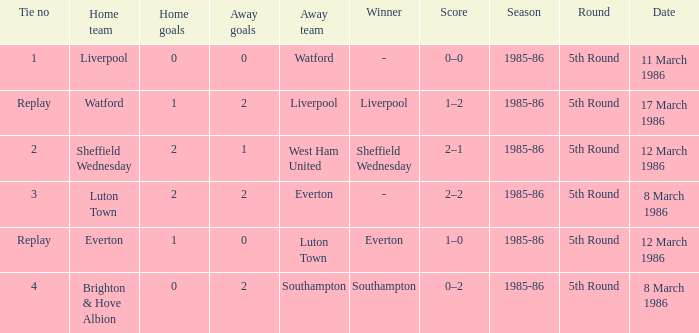What transpired with southampton's tie? 4.0. Can you give me this table as a dict? {'header': ['Tie no', 'Home team', 'Home goals', 'Away goals', 'Away team', 'Winner', 'Score', 'Season', 'Round', 'Date'], 'rows': [['1', 'Liverpool', '0', '0', 'Watford', '-', '0–0', '1985-86', '5th Round', '11 March 1986'], ['Replay', 'Watford', '1', '2', 'Liverpool', 'Liverpool', '1–2', '1985-86', '5th Round', '17 March 1986'], ['2', 'Sheffield Wednesday', '2', '1', 'West Ham United', 'Sheffield Wednesday', '2–1', '1985-86', '5th Round', '12 March 1986'], ['3', 'Luton Town', '2', '2', 'Everton', '-', '2–2', '1985-86', '5th Round', '8 March 1986'], ['Replay', 'Everton', '1', '0', 'Luton Town', 'Everton', '1–0', '1985-86', '5th Round', '12 March 1986'], ['4', 'Brighton & Hove Albion', '0', '2', 'Southampton', 'Southampton', '0–2', '1985-86', '5th Round', '8 March 1986']]} 